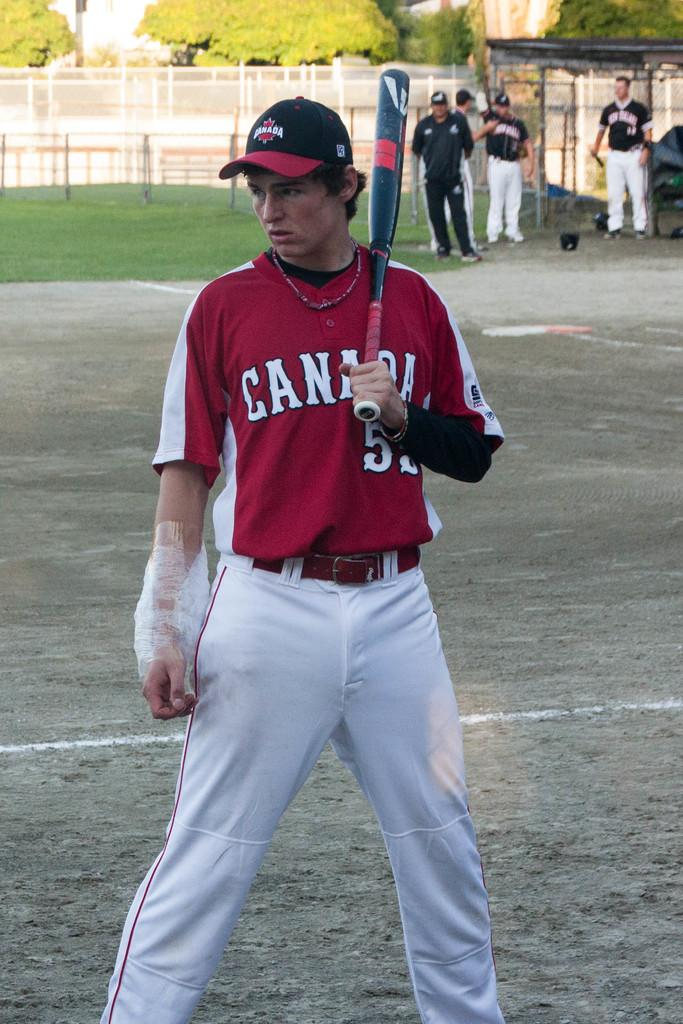Provide a one-sentence caption for the provided image. A Canada man is up to bat wearing his red jersey. 